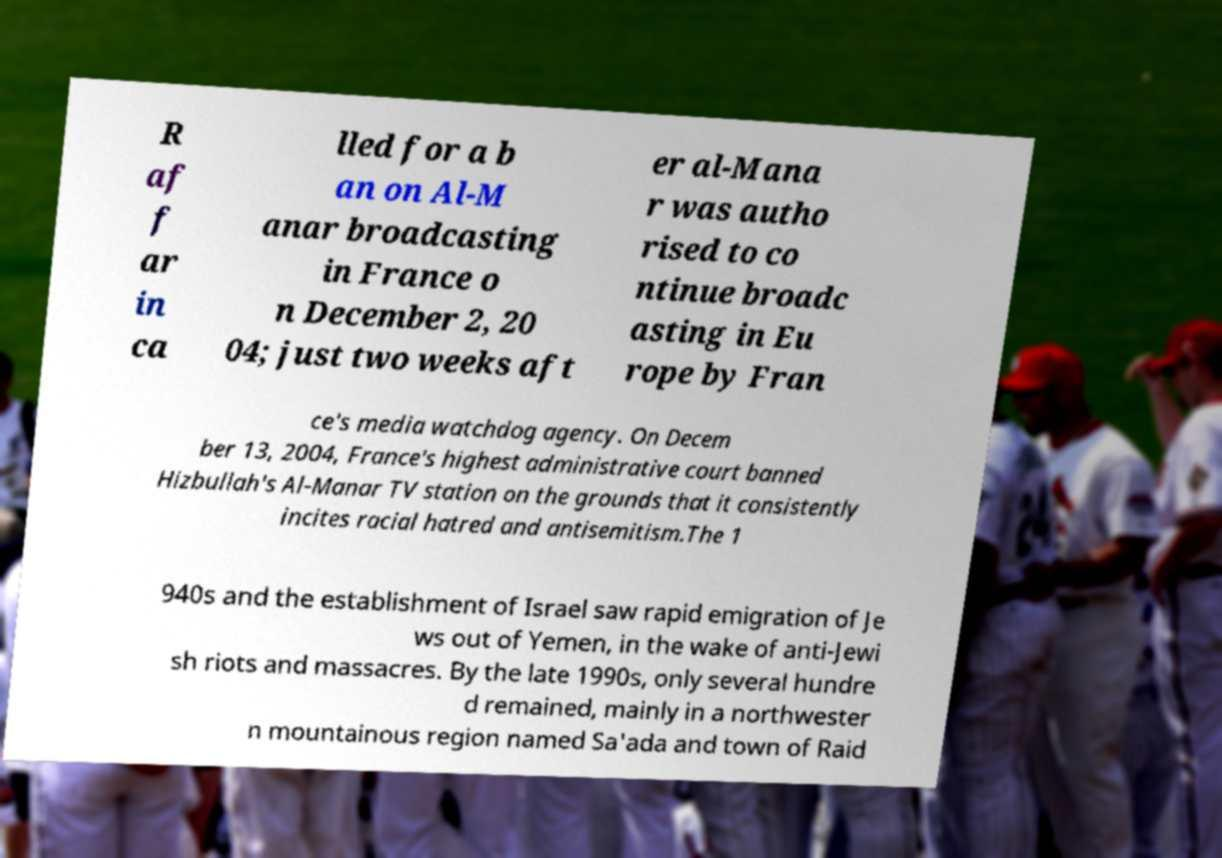There's text embedded in this image that I need extracted. Can you transcribe it verbatim? R af f ar in ca lled for a b an on Al-M anar broadcasting in France o n December 2, 20 04; just two weeks aft er al-Mana r was autho rised to co ntinue broadc asting in Eu rope by Fran ce's media watchdog agency. On Decem ber 13, 2004, France's highest administrative court banned Hizbullah's Al-Manar TV station on the grounds that it consistently incites racial hatred and antisemitism.The 1 940s and the establishment of Israel saw rapid emigration of Je ws out of Yemen, in the wake of anti-Jewi sh riots and massacres. By the late 1990s, only several hundre d remained, mainly in a northwester n mountainous region named Sa'ada and town of Raid 